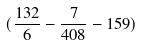<formula> <loc_0><loc_0><loc_500><loc_500>( \frac { 1 3 2 } { 6 } - \frac { 7 } { 4 0 8 } - 1 5 9 )</formula> 